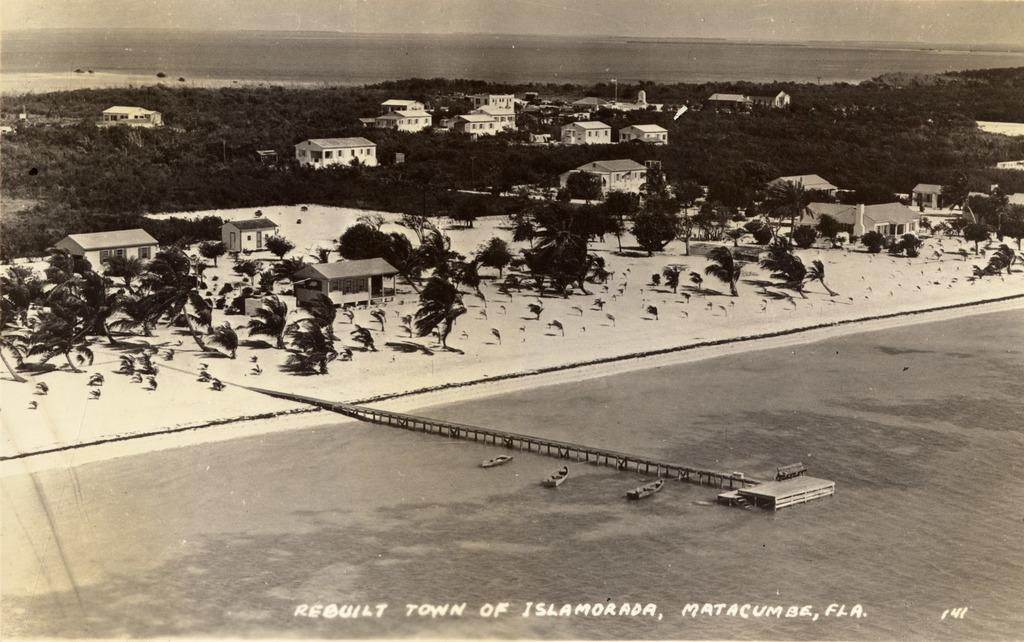<image>
Share a concise interpretation of the image provided. a picture that says 'rebuilt town of islamorada, matacumas, fla.' at the bottom of it 